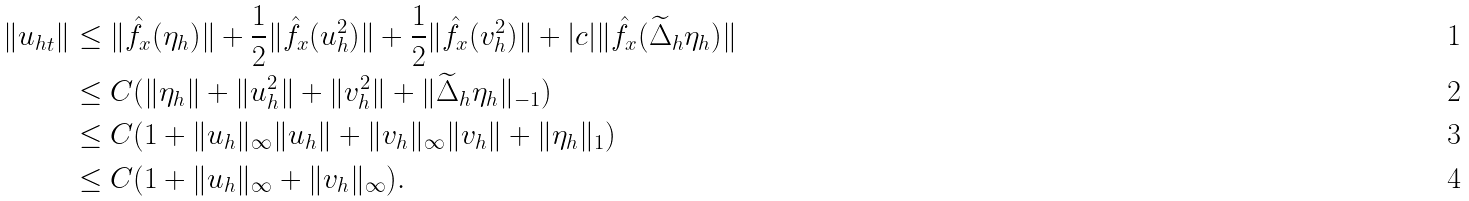<formula> <loc_0><loc_0><loc_500><loc_500>\| { u _ { h } } _ { t } \| & \leq \| \hat { f } _ { x } ( \eta _ { h } ) \| + \frac { 1 } { 2 } \| \hat { f } _ { x } ( u _ { h } ^ { 2 } ) \| + \frac { 1 } { 2 } \| \hat { f } _ { x } ( v _ { h } ^ { 2 } ) \| + | c | \| \hat { f } _ { x } ( \widetilde { \Delta } _ { h } \eta _ { h } ) \| \\ & \leq C ( \| \eta _ { h } \| + \| u _ { h } ^ { 2 } \| + \| v _ { h } ^ { 2 } \| + \| \widetilde { \Delta } _ { h } \eta _ { h } \| _ { - 1 } ) \\ & \leq C ( 1 + \| u _ { h } \| _ { \infty } \| u _ { h } \| + \| v _ { h } \| _ { \infty } \| v _ { h } \| + \| \eta _ { h } \| _ { 1 } ) \\ & \leq C ( 1 + \| u _ { h } \| _ { \infty } + \| v _ { h } \| _ { \infty } ) .</formula> 